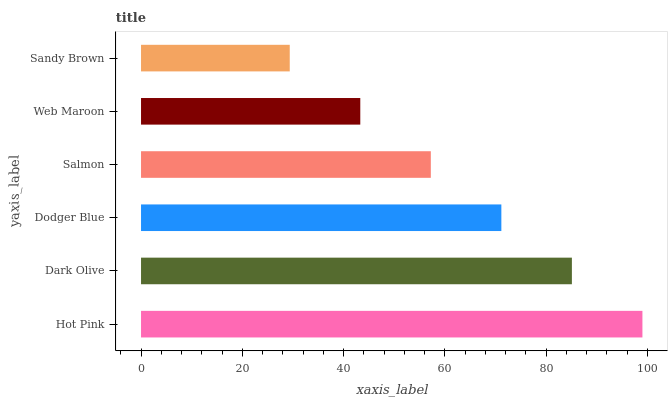Is Sandy Brown the minimum?
Answer yes or no. Yes. Is Hot Pink the maximum?
Answer yes or no. Yes. Is Dark Olive the minimum?
Answer yes or no. No. Is Dark Olive the maximum?
Answer yes or no. No. Is Hot Pink greater than Dark Olive?
Answer yes or no. Yes. Is Dark Olive less than Hot Pink?
Answer yes or no. Yes. Is Dark Olive greater than Hot Pink?
Answer yes or no. No. Is Hot Pink less than Dark Olive?
Answer yes or no. No. Is Dodger Blue the high median?
Answer yes or no. Yes. Is Salmon the low median?
Answer yes or no. Yes. Is Hot Pink the high median?
Answer yes or no. No. Is Sandy Brown the low median?
Answer yes or no. No. 